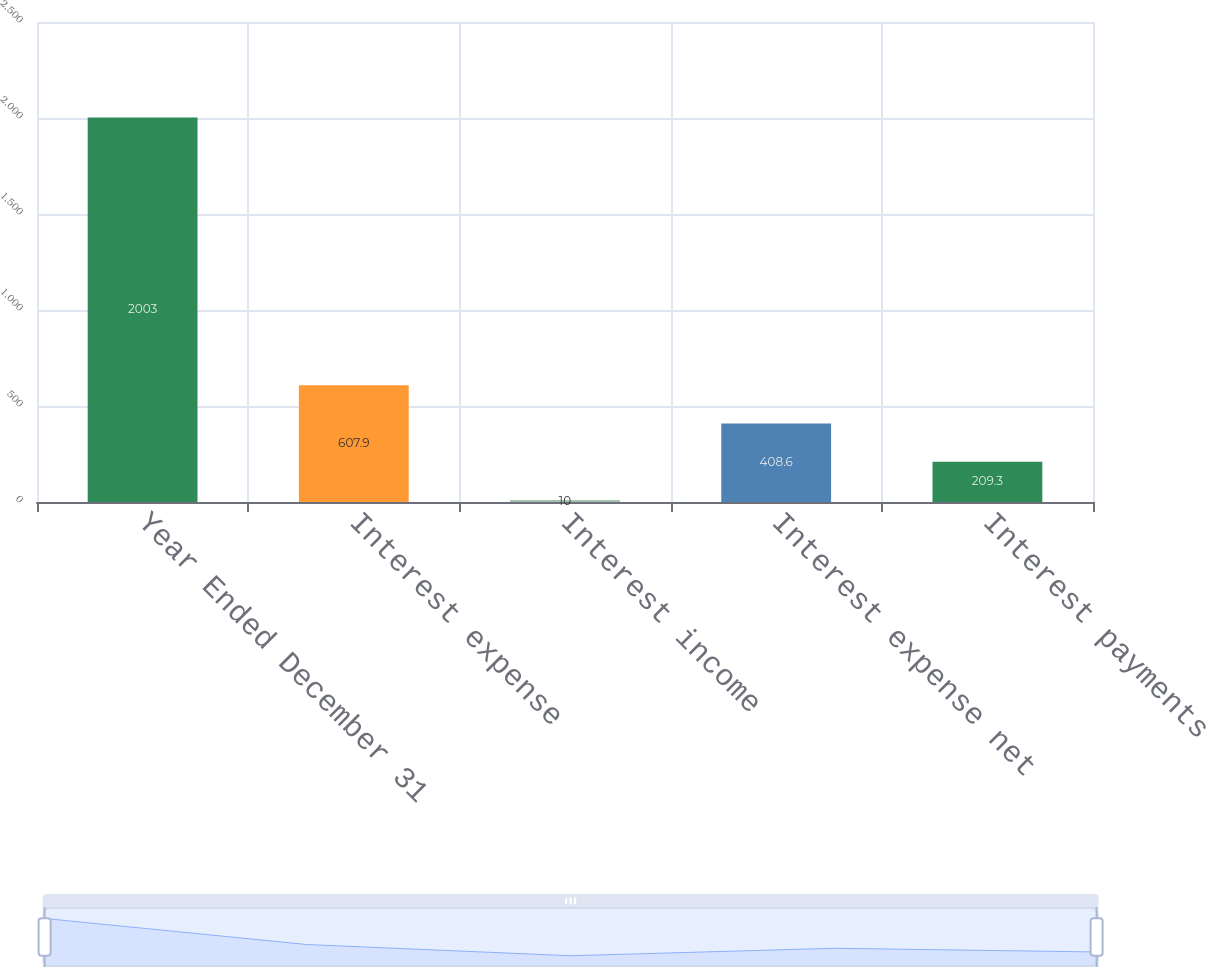Convert chart. <chart><loc_0><loc_0><loc_500><loc_500><bar_chart><fcel>Year Ended December 31<fcel>Interest expense<fcel>Interest income<fcel>Interest expense net<fcel>Interest payments<nl><fcel>2003<fcel>607.9<fcel>10<fcel>408.6<fcel>209.3<nl></chart> 